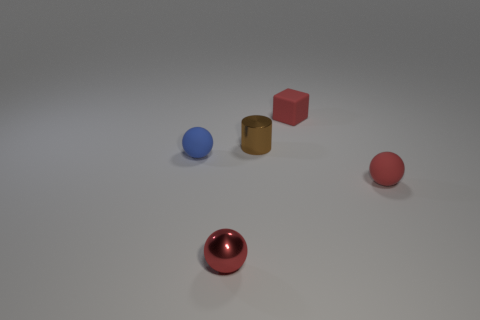The tiny thing that is both behind the tiny red rubber sphere and right of the small cylinder has what shape?
Make the answer very short. Cube. There is another ball that is the same color as the small metal sphere; what is it made of?
Provide a succinct answer. Rubber. Is the color of the metallic cylinder the same as the cube?
Keep it short and to the point. No. What is the material of the red object that is behind the ball behind the red matte thing in front of the tiny brown cylinder?
Make the answer very short. Rubber. What number of objects are tiny shiny objects in front of the metal cylinder or tiny brown metallic things?
Your answer should be very brief. 2. What number of other things are there of the same shape as the brown thing?
Your answer should be very brief. 0. Are there more red rubber cubes to the right of the red block than large blue spheres?
Give a very brief answer. No. What size is the other red object that is the same shape as the red metal object?
Keep it short and to the point. Small. Is there any other thing that has the same material as the tiny cube?
Your answer should be very brief. Yes. What shape is the tiny blue thing?
Give a very brief answer. Sphere. 